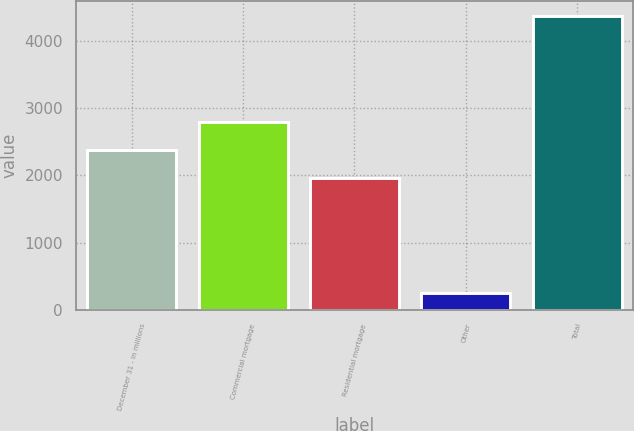Convert chart to OTSL. <chart><loc_0><loc_0><loc_500><loc_500><bar_chart><fcel>December 31 - in millions<fcel>Commercial mortgage<fcel>Residential mortgage<fcel>Other<fcel>Total<nl><fcel>2374<fcel>2786<fcel>1962<fcel>246<fcel>4366<nl></chart> 